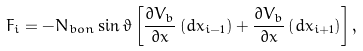<formula> <loc_0><loc_0><loc_500><loc_500>F _ { i } = - N _ { b o n } \sin { \vartheta } \left [ \frac { \partial V _ { b } } { \partial x } \left ( d x _ { i - 1 } \right ) + \frac { \partial V _ { b } } { \partial x } \left ( d x _ { i + 1 } \right ) \right ] ,</formula> 